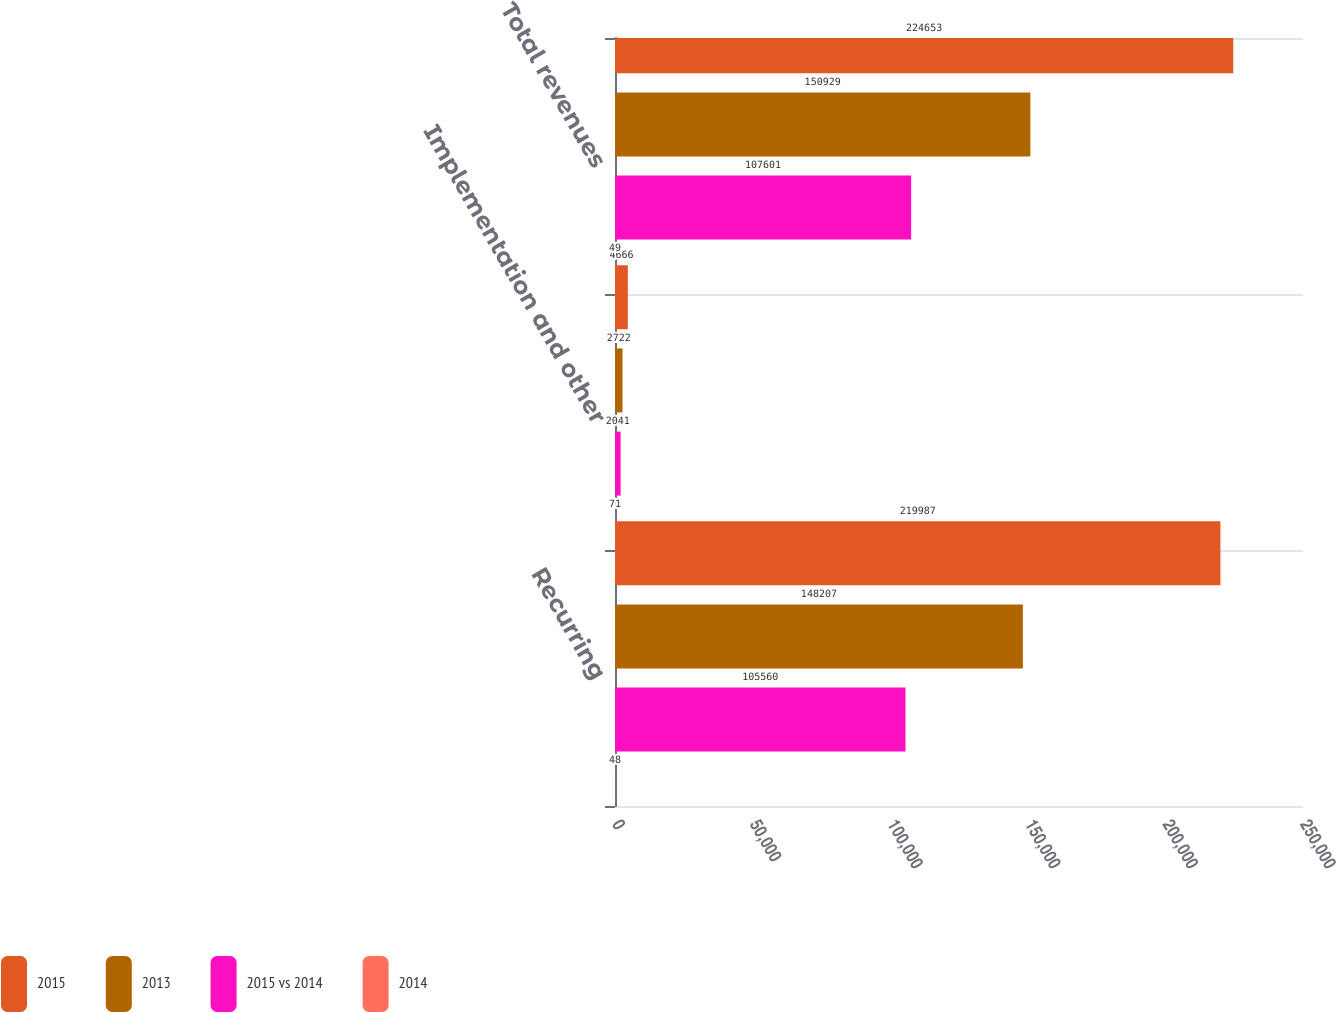Convert chart. <chart><loc_0><loc_0><loc_500><loc_500><stacked_bar_chart><ecel><fcel>Recurring<fcel>Implementation and other<fcel>Total revenues<nl><fcel>2015<fcel>219987<fcel>4666<fcel>224653<nl><fcel>2013<fcel>148207<fcel>2722<fcel>150929<nl><fcel>2015 vs 2014<fcel>105560<fcel>2041<fcel>107601<nl><fcel>2014<fcel>48<fcel>71<fcel>49<nl></chart> 